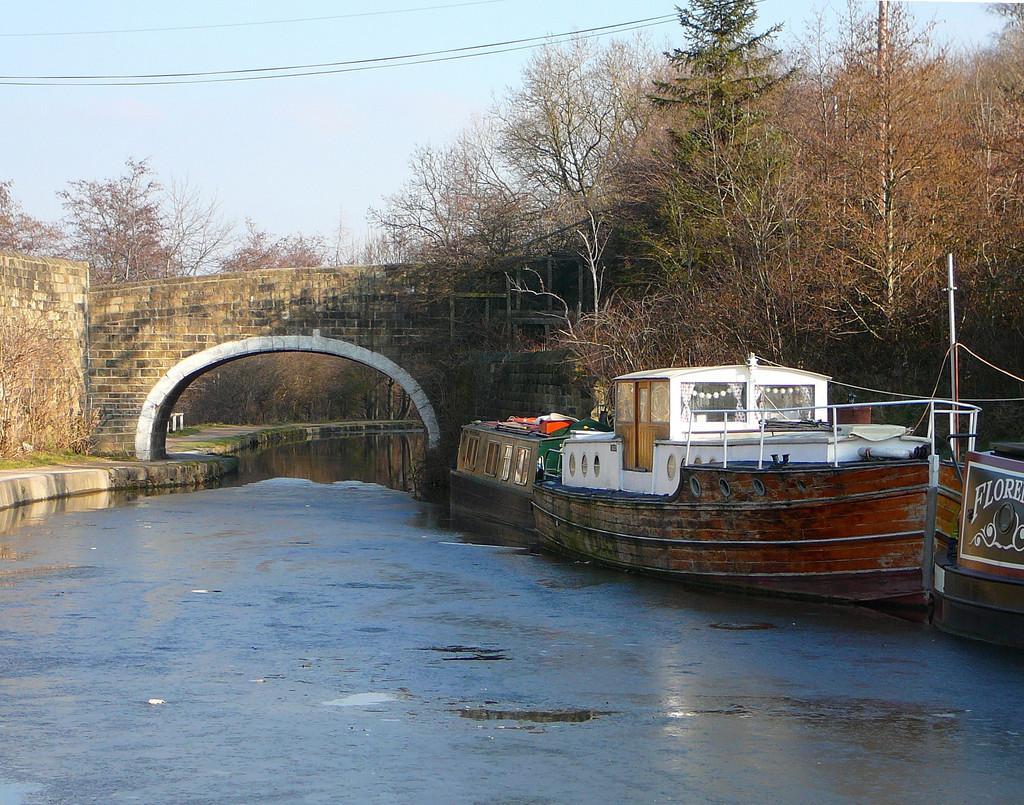In one or two sentences, can you explain what this image depicts? On the right side, there are boats parked on the water, near trees. On the left side, there is footpath, near the wall. In the background, there is a bridge, which is built across the river, there are trees, there are electrical lines and there is blue sky. 